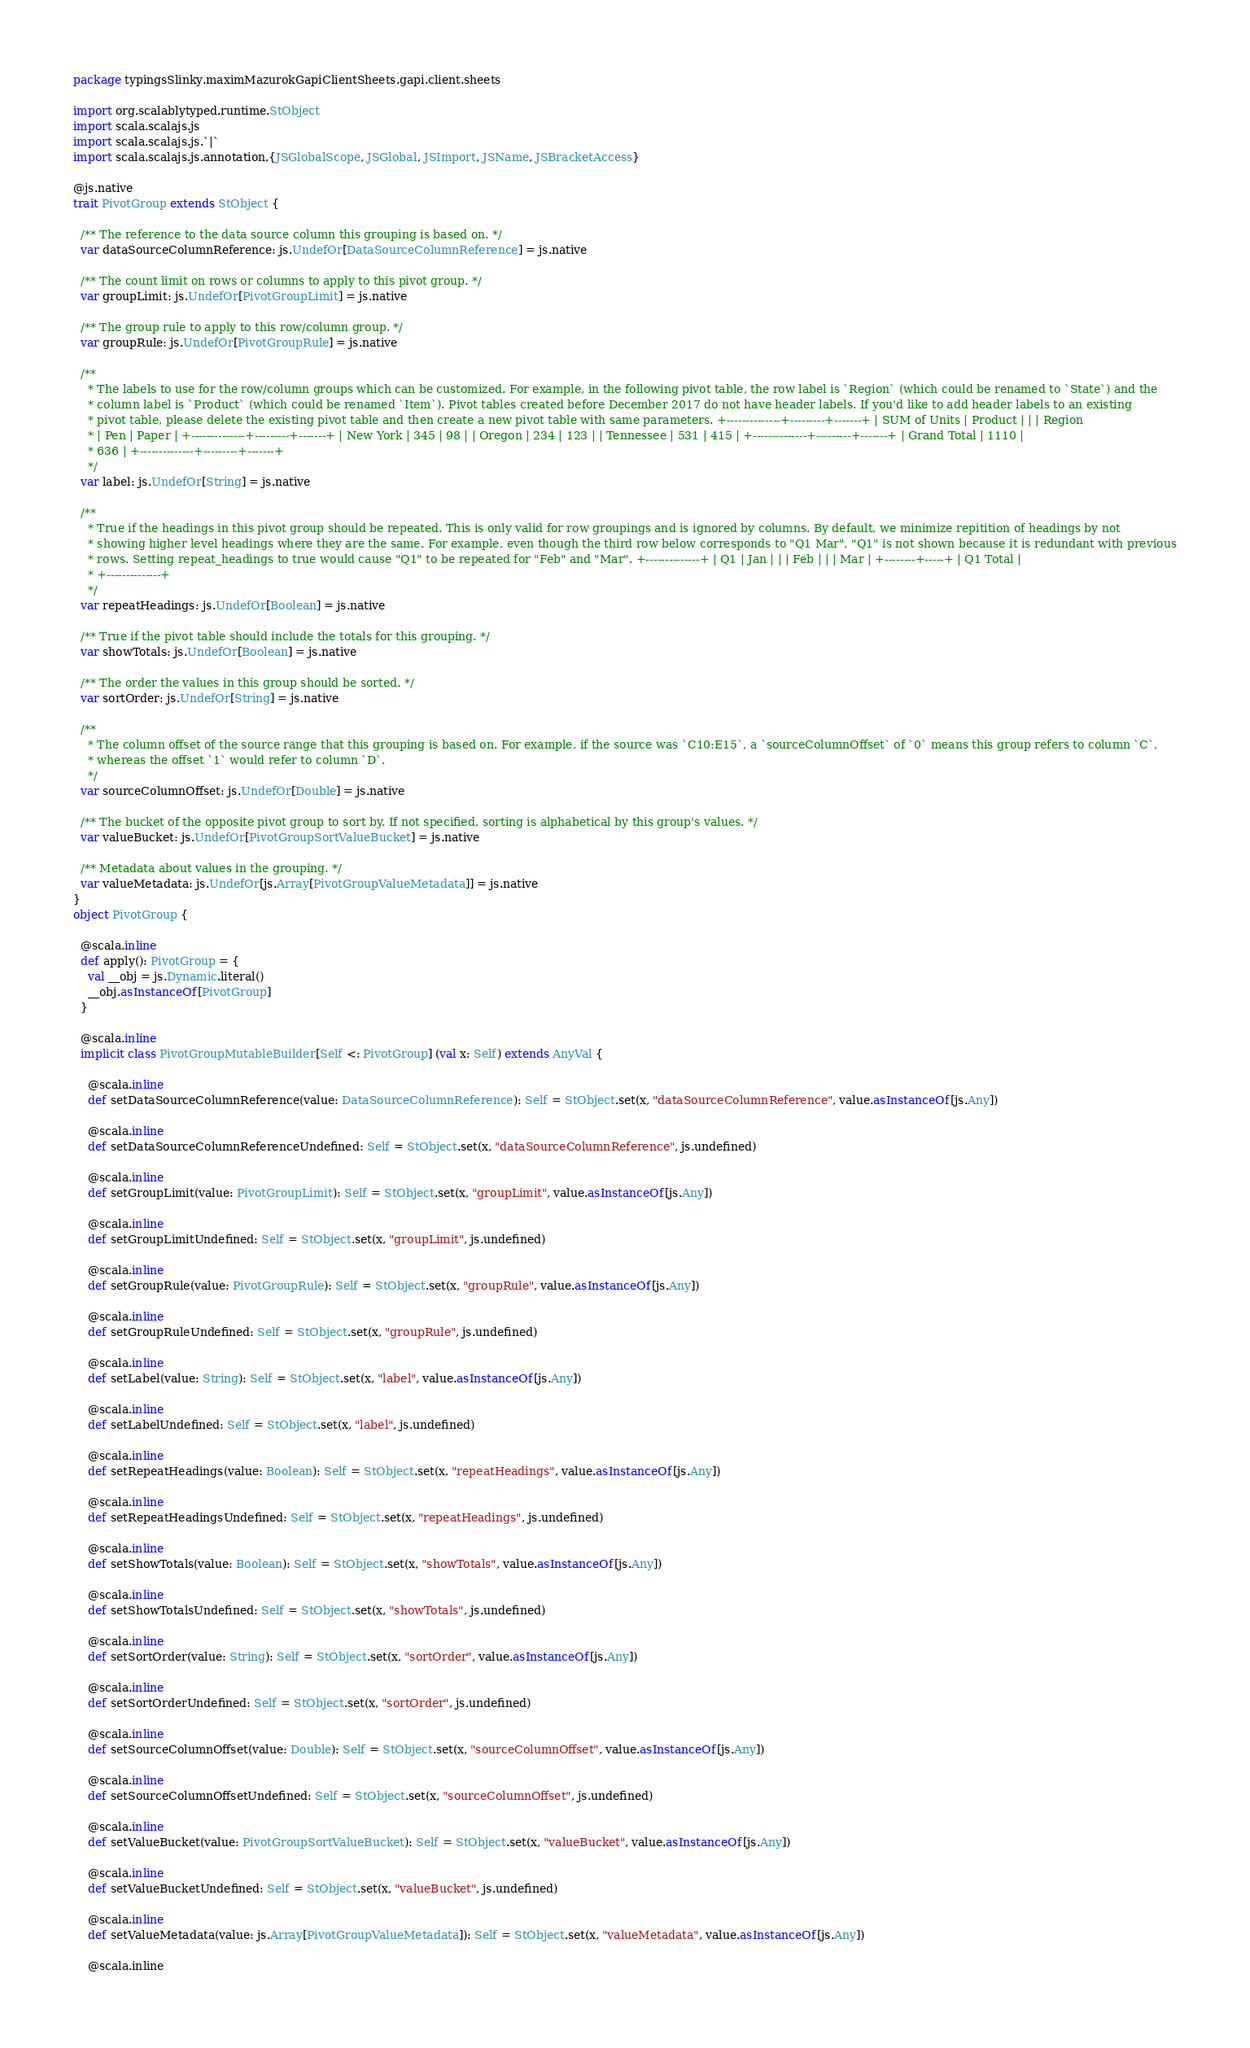<code> <loc_0><loc_0><loc_500><loc_500><_Scala_>package typingsSlinky.maximMazurokGapiClientSheets.gapi.client.sheets

import org.scalablytyped.runtime.StObject
import scala.scalajs.js
import scala.scalajs.js.`|`
import scala.scalajs.js.annotation.{JSGlobalScope, JSGlobal, JSImport, JSName, JSBracketAccess}

@js.native
trait PivotGroup extends StObject {
  
  /** The reference to the data source column this grouping is based on. */
  var dataSourceColumnReference: js.UndefOr[DataSourceColumnReference] = js.native
  
  /** The count limit on rows or columns to apply to this pivot group. */
  var groupLimit: js.UndefOr[PivotGroupLimit] = js.native
  
  /** The group rule to apply to this row/column group. */
  var groupRule: js.UndefOr[PivotGroupRule] = js.native
  
  /**
    * The labels to use for the row/column groups which can be customized. For example, in the following pivot table, the row label is `Region` (which could be renamed to `State`) and the
    * column label is `Product` (which could be renamed `Item`). Pivot tables created before December 2017 do not have header labels. If you'd like to add header labels to an existing
    * pivot table, please delete the existing pivot table and then create a new pivot table with same parameters. +--------------+---------+-------+ | SUM of Units | Product | | | Region
    * | Pen | Paper | +--------------+---------+-------+ | New York | 345 | 98 | | Oregon | 234 | 123 | | Tennessee | 531 | 415 | +--------------+---------+-------+ | Grand Total | 1110 |
    * 636 | +--------------+---------+-------+
    */
  var label: js.UndefOr[String] = js.native
  
  /**
    * True if the headings in this pivot group should be repeated. This is only valid for row groupings and is ignored by columns. By default, we minimize repitition of headings by not
    * showing higher level headings where they are the same. For example, even though the third row below corresponds to "Q1 Mar", "Q1" is not shown because it is redundant with previous
    * rows. Setting repeat_headings to true would cause "Q1" to be repeated for "Feb" and "Mar". +--------------+ | Q1 | Jan | | | Feb | | | Mar | +--------+-----+ | Q1 Total |
    * +--------------+
    */
  var repeatHeadings: js.UndefOr[Boolean] = js.native
  
  /** True if the pivot table should include the totals for this grouping. */
  var showTotals: js.UndefOr[Boolean] = js.native
  
  /** The order the values in this group should be sorted. */
  var sortOrder: js.UndefOr[String] = js.native
  
  /**
    * The column offset of the source range that this grouping is based on. For example, if the source was `C10:E15`, a `sourceColumnOffset` of `0` means this group refers to column `C`,
    * whereas the offset `1` would refer to column `D`.
    */
  var sourceColumnOffset: js.UndefOr[Double] = js.native
  
  /** The bucket of the opposite pivot group to sort by. If not specified, sorting is alphabetical by this group's values. */
  var valueBucket: js.UndefOr[PivotGroupSortValueBucket] = js.native
  
  /** Metadata about values in the grouping. */
  var valueMetadata: js.UndefOr[js.Array[PivotGroupValueMetadata]] = js.native
}
object PivotGroup {
  
  @scala.inline
  def apply(): PivotGroup = {
    val __obj = js.Dynamic.literal()
    __obj.asInstanceOf[PivotGroup]
  }
  
  @scala.inline
  implicit class PivotGroupMutableBuilder[Self <: PivotGroup] (val x: Self) extends AnyVal {
    
    @scala.inline
    def setDataSourceColumnReference(value: DataSourceColumnReference): Self = StObject.set(x, "dataSourceColumnReference", value.asInstanceOf[js.Any])
    
    @scala.inline
    def setDataSourceColumnReferenceUndefined: Self = StObject.set(x, "dataSourceColumnReference", js.undefined)
    
    @scala.inline
    def setGroupLimit(value: PivotGroupLimit): Self = StObject.set(x, "groupLimit", value.asInstanceOf[js.Any])
    
    @scala.inline
    def setGroupLimitUndefined: Self = StObject.set(x, "groupLimit", js.undefined)
    
    @scala.inline
    def setGroupRule(value: PivotGroupRule): Self = StObject.set(x, "groupRule", value.asInstanceOf[js.Any])
    
    @scala.inline
    def setGroupRuleUndefined: Self = StObject.set(x, "groupRule", js.undefined)
    
    @scala.inline
    def setLabel(value: String): Self = StObject.set(x, "label", value.asInstanceOf[js.Any])
    
    @scala.inline
    def setLabelUndefined: Self = StObject.set(x, "label", js.undefined)
    
    @scala.inline
    def setRepeatHeadings(value: Boolean): Self = StObject.set(x, "repeatHeadings", value.asInstanceOf[js.Any])
    
    @scala.inline
    def setRepeatHeadingsUndefined: Self = StObject.set(x, "repeatHeadings", js.undefined)
    
    @scala.inline
    def setShowTotals(value: Boolean): Self = StObject.set(x, "showTotals", value.asInstanceOf[js.Any])
    
    @scala.inline
    def setShowTotalsUndefined: Self = StObject.set(x, "showTotals", js.undefined)
    
    @scala.inline
    def setSortOrder(value: String): Self = StObject.set(x, "sortOrder", value.asInstanceOf[js.Any])
    
    @scala.inline
    def setSortOrderUndefined: Self = StObject.set(x, "sortOrder", js.undefined)
    
    @scala.inline
    def setSourceColumnOffset(value: Double): Self = StObject.set(x, "sourceColumnOffset", value.asInstanceOf[js.Any])
    
    @scala.inline
    def setSourceColumnOffsetUndefined: Self = StObject.set(x, "sourceColumnOffset", js.undefined)
    
    @scala.inline
    def setValueBucket(value: PivotGroupSortValueBucket): Self = StObject.set(x, "valueBucket", value.asInstanceOf[js.Any])
    
    @scala.inline
    def setValueBucketUndefined: Self = StObject.set(x, "valueBucket", js.undefined)
    
    @scala.inline
    def setValueMetadata(value: js.Array[PivotGroupValueMetadata]): Self = StObject.set(x, "valueMetadata", value.asInstanceOf[js.Any])
    
    @scala.inline</code> 